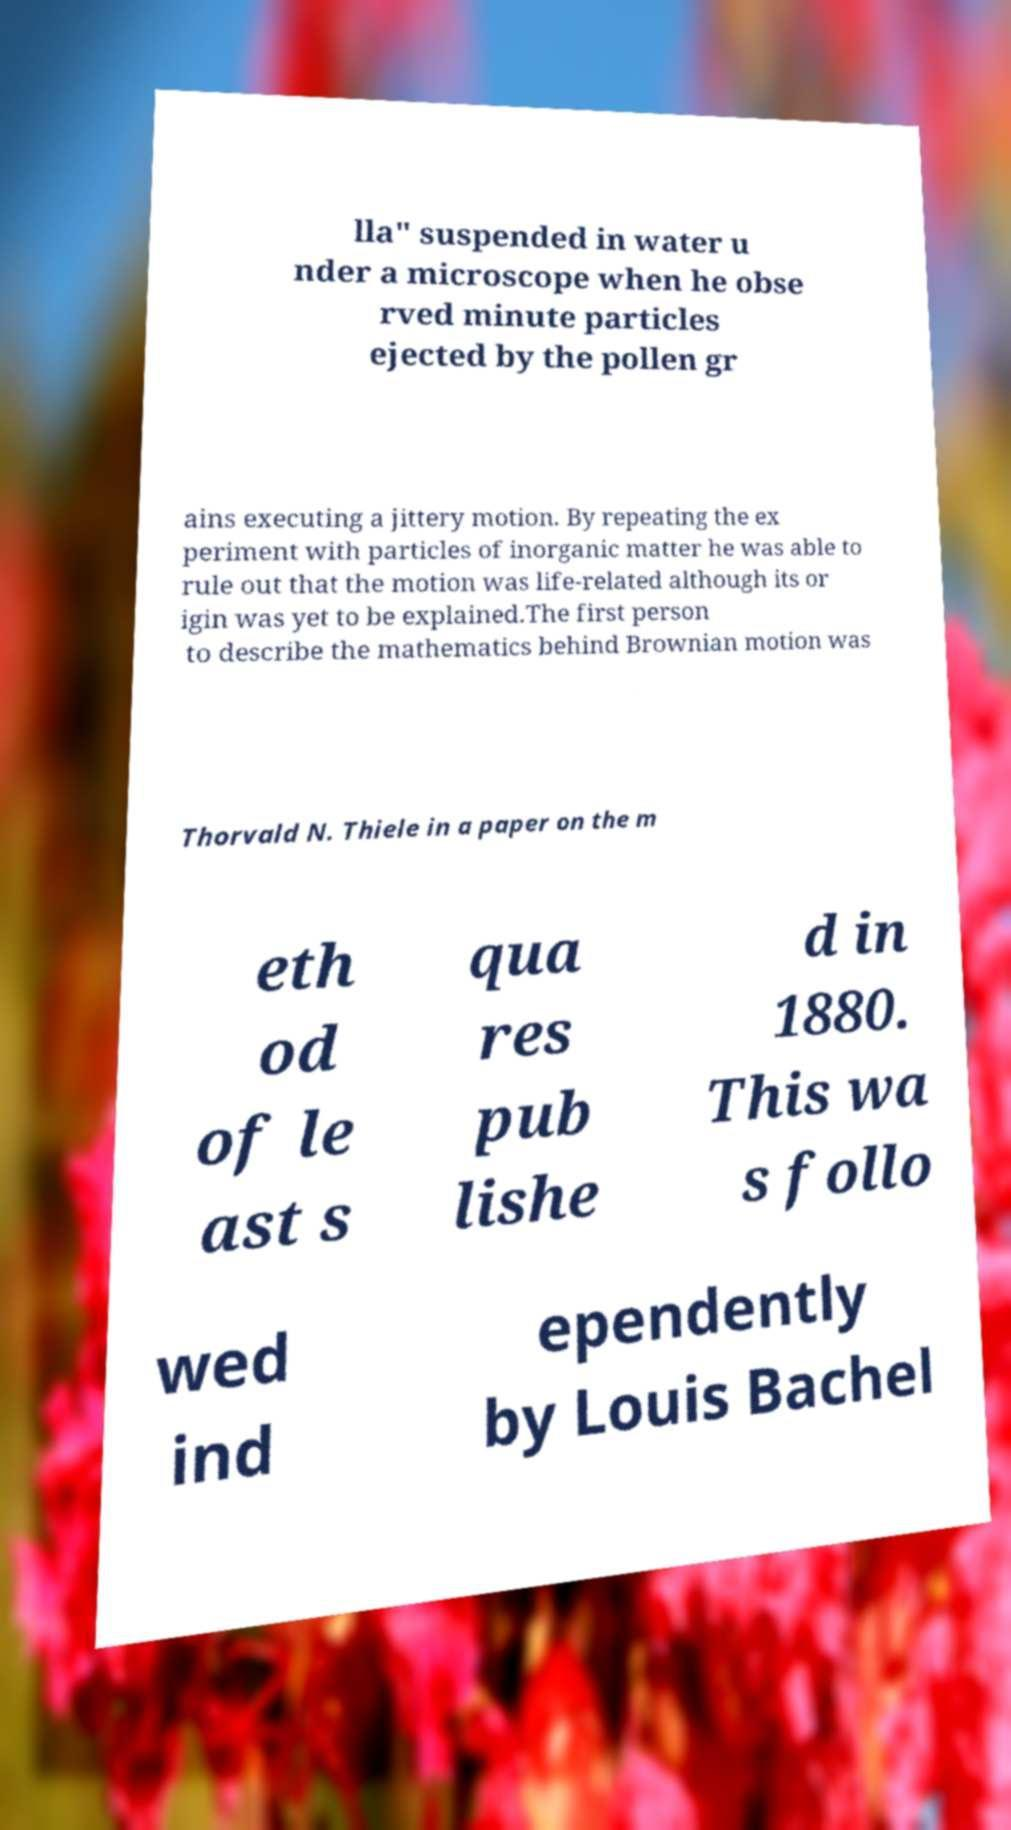What messages or text are displayed in this image? I need them in a readable, typed format. lla" suspended in water u nder a microscope when he obse rved minute particles ejected by the pollen gr ains executing a jittery motion. By repeating the ex periment with particles of inorganic matter he was able to rule out that the motion was life-related although its or igin was yet to be explained.The first person to describe the mathematics behind Brownian motion was Thorvald N. Thiele in a paper on the m eth od of le ast s qua res pub lishe d in 1880. This wa s follo wed ind ependently by Louis Bachel 